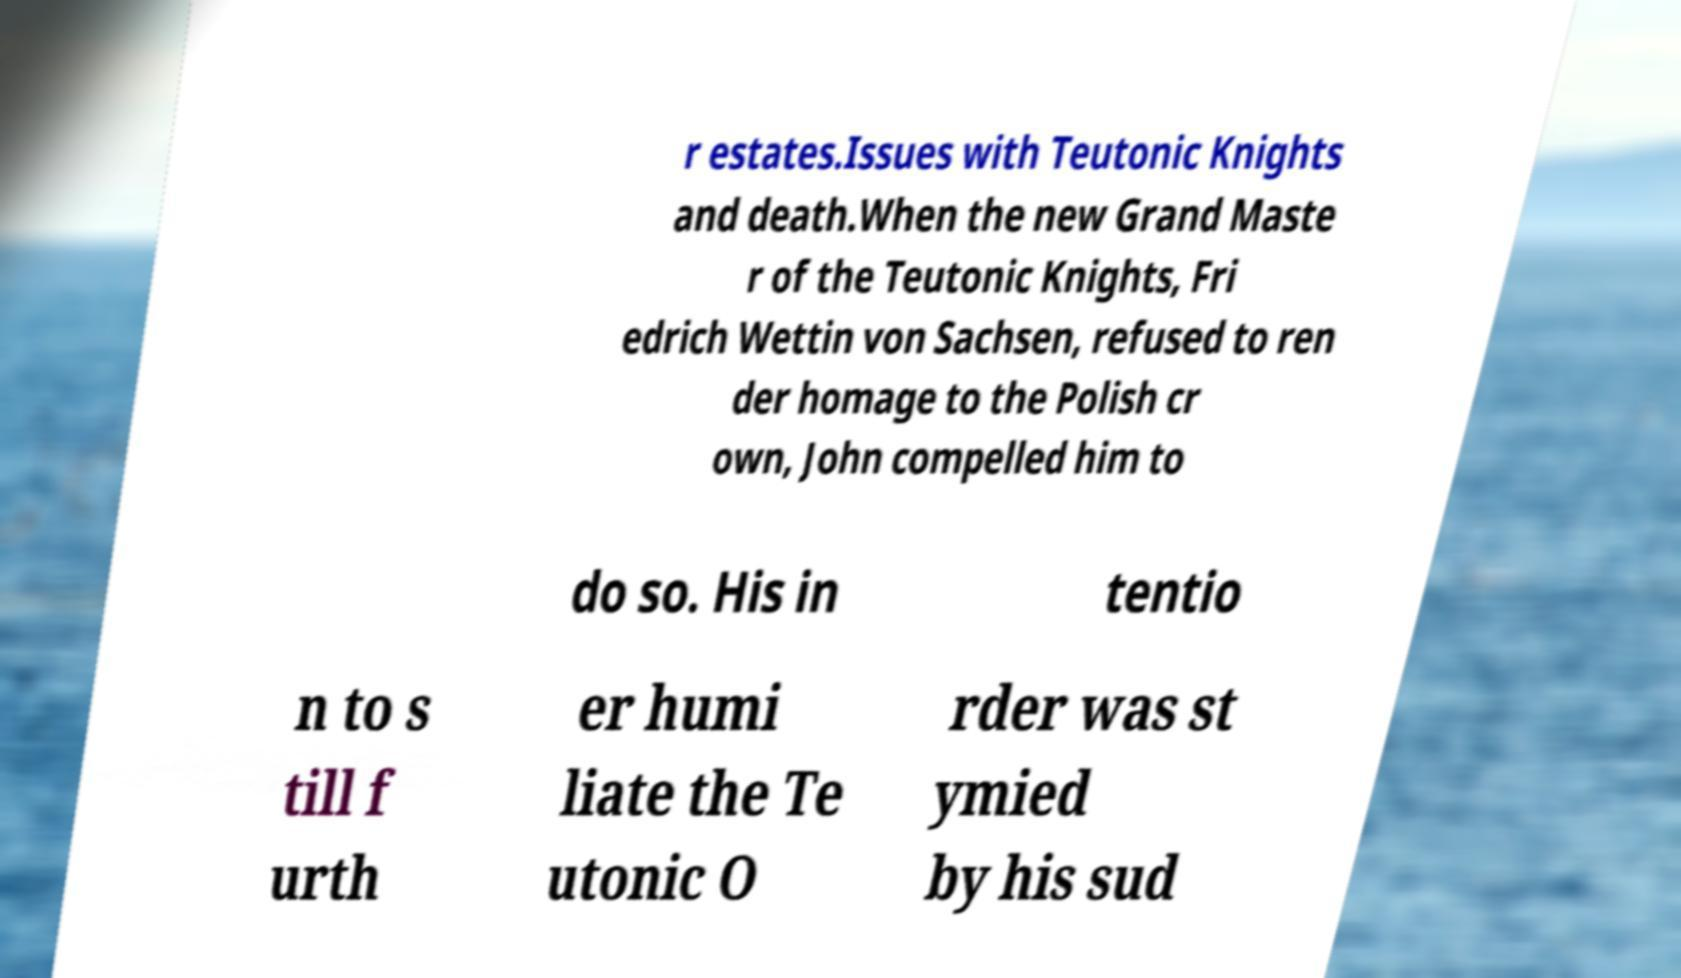There's text embedded in this image that I need extracted. Can you transcribe it verbatim? r estates.Issues with Teutonic Knights and death.When the new Grand Maste r of the Teutonic Knights, Fri edrich Wettin von Sachsen, refused to ren der homage to the Polish cr own, John compelled him to do so. His in tentio n to s till f urth er humi liate the Te utonic O rder was st ymied by his sud 